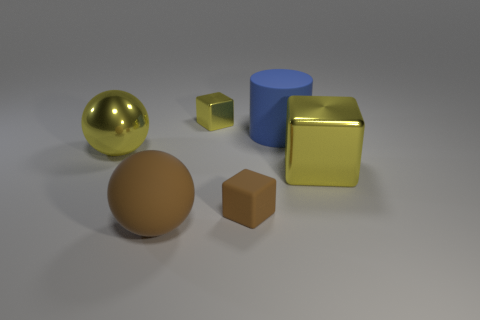Add 2 red shiny blocks. How many objects exist? 8 Subtract all spheres. How many objects are left? 4 Add 3 shiny balls. How many shiny balls exist? 4 Subtract 1 brown spheres. How many objects are left? 5 Subtract all metal cubes. Subtract all rubber objects. How many objects are left? 1 Add 1 large brown objects. How many large brown objects are left? 2 